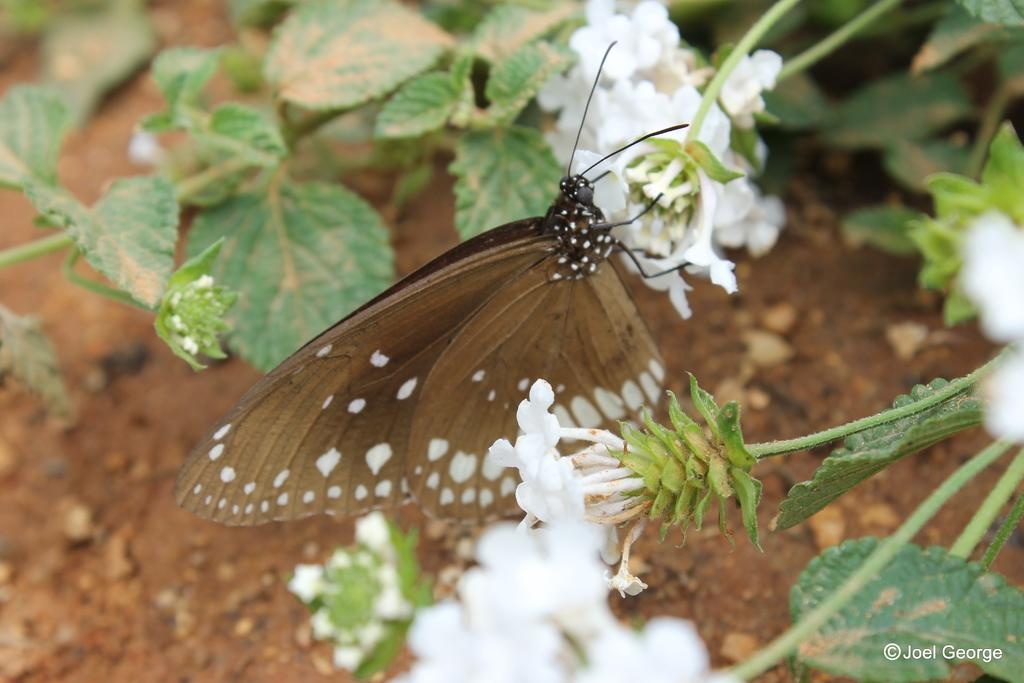What is the main subject of the image? There is a butterfly in the image. Where is the butterfly located? The butterfly is on flowers of a plant. What can be seen in the background of the image? There is a group of leaves in the background of the image. What type of linen is used to make the butterfly's wings in the image? The butterfly's wings are not made of linen; they are natural wings of a butterfly. How does the butterfly taste in the image? Butterflies are not edible, so there is no taste associated with the butterfly in the image. 